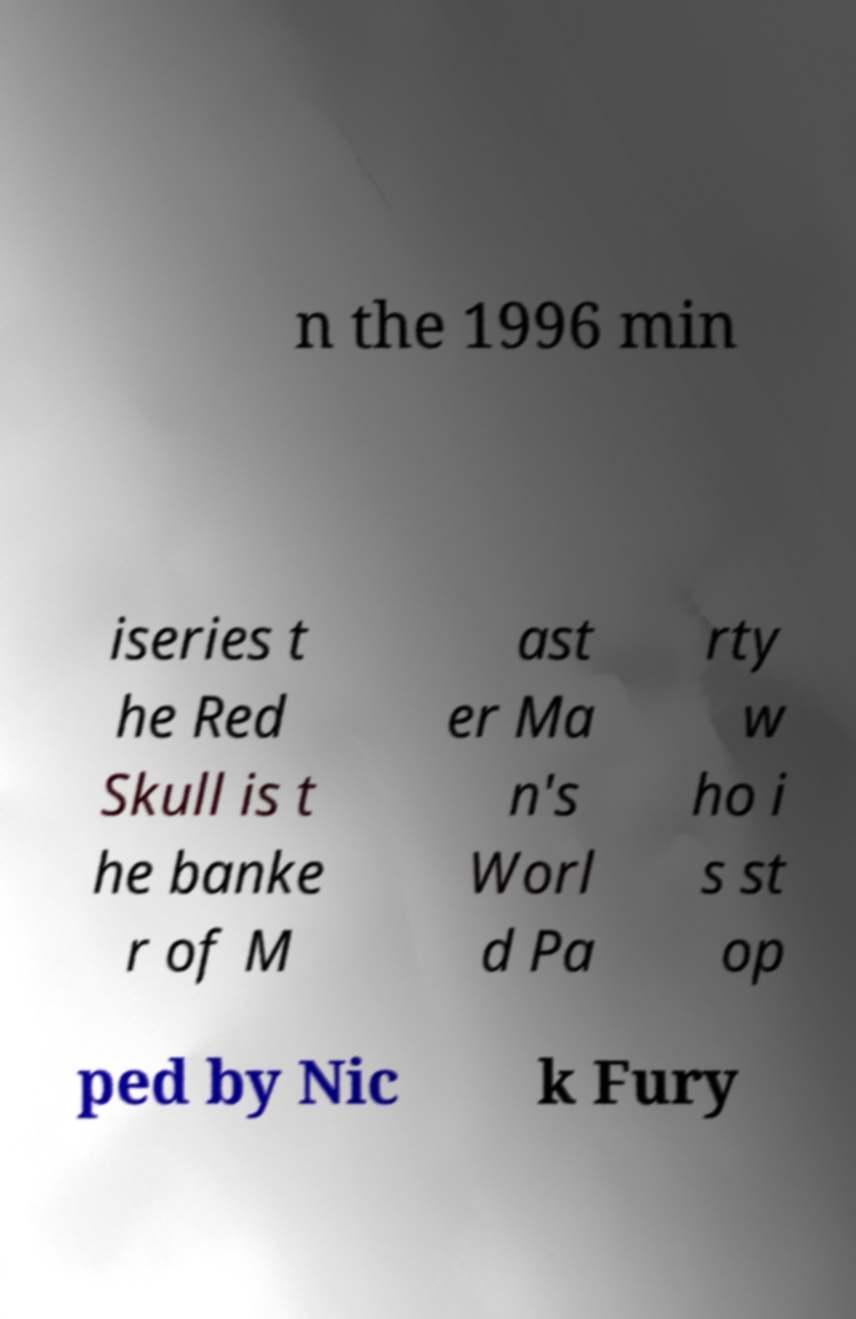There's text embedded in this image that I need extracted. Can you transcribe it verbatim? n the 1996 min iseries t he Red Skull is t he banke r of M ast er Ma n's Worl d Pa rty w ho i s st op ped by Nic k Fury 